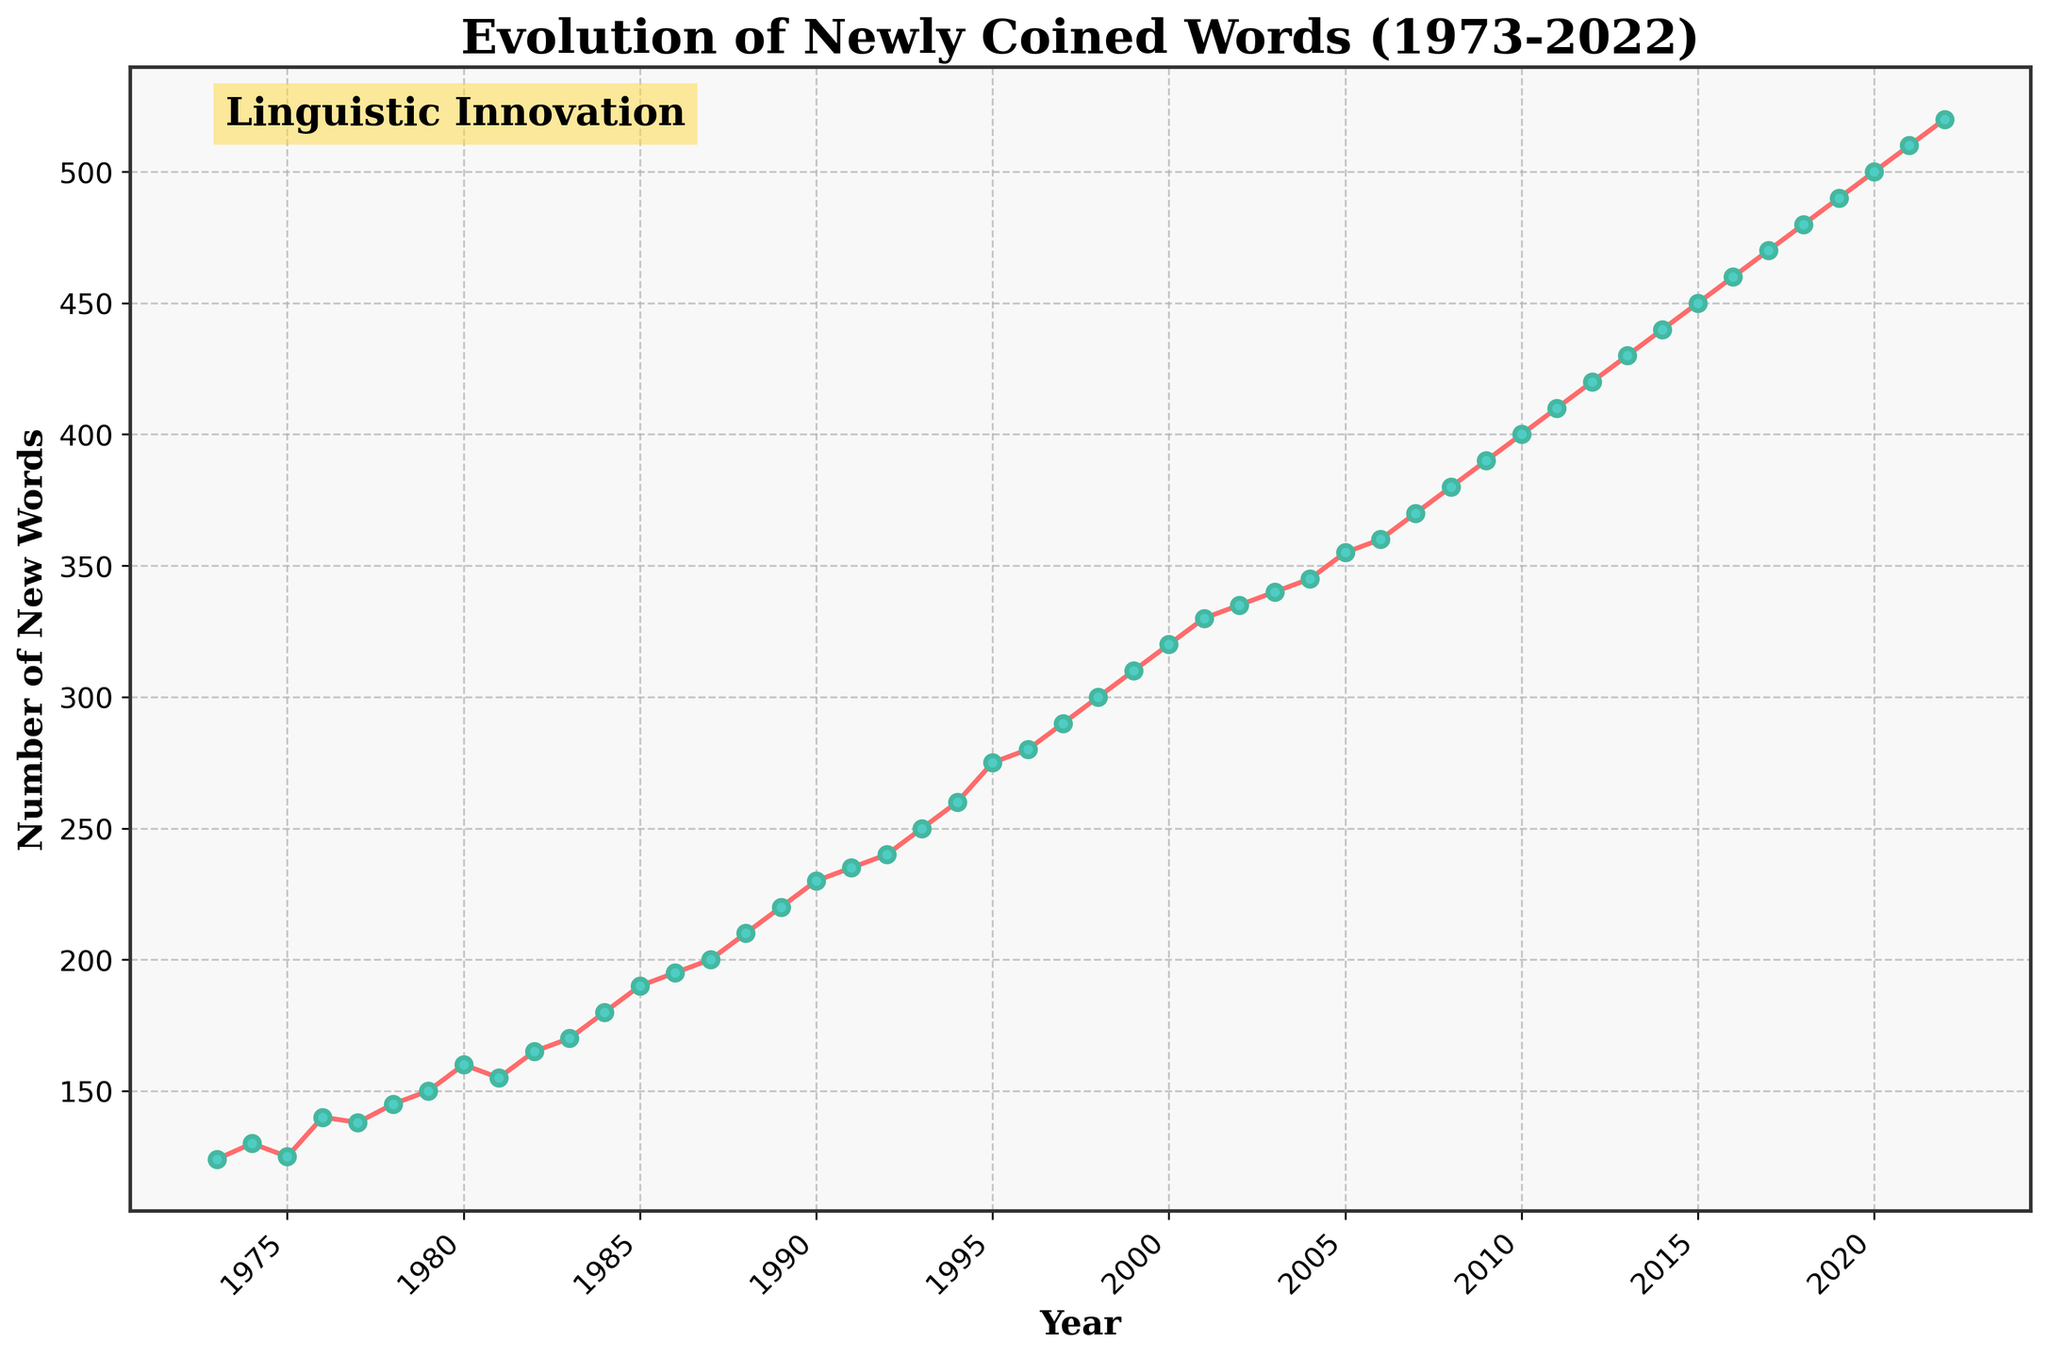What is the title of the plot? The title is located at the top center of the plot. By examining the figure, the title reads "Evolution of Newly Coined Words (1973-2022)."
Answer: Evolution of Newly Coined Words (1973-2022) What does the y-axis represent? The y-axis typically represents the variable of interest in a time series plot. Here, it is labeled "Number of New Words," denoting the count of newly coined words.
Answer: Number of New Words How many years does the data span? By looking at the x-axis, we can see the range of years from the start to the end. It begins at 1973 and ends at 2022. The timespan is 2022 - 1973 + 1 (inclusive).
Answer: 50 years In which year did the count of newly coined words reach 500? Reviewing the plot and y-axis, we find the point where the count is closest to 500, which falls on the year 2020.
Answer: 2020 What was the number of new words in 1985? By locating the year 1985 on the x-axis and tracing upward to intersect the line, the y-axis indicates the count, which is 190.
Answer: 190 What is the average number of newly coined words from 1973 to 1983? To find the average, sum the counts from 1973 to 1983 and divide by the number of years (11). This is (124 + 130 + 125 + 140 + 138 + 145 + 150 + 160 + 155 + 165 + 170) / 11.
Answer: 149 Compare the number of new words in 1990 and 2000. Which year had more newly coined words? By examining the y-axis values for the years 1990 and 2000, we see that 1990 had 230 and 2000 had 320. Thus, the year 2000 had more newly coined words.
Answer: 2000 From 1980 to 1990, which year had the steepest increase in newly coined words? By evaluating the slope of the line between successive years from 1980 to 1990, the year-to-year differences can be compared. The steepest increase occurs between 1984 (180) and 1985 (190), a change of +10.
Answer: 1985 What was the rate of increase in newly coined words per year from 2010 to 2020? Calculate the difference in counts between 2020 and 2010, then divide by the number of years. (500 - 400) / (2020 - 2010) = 10 words per year.
Answer: 10 words per year Identify the decade with the highest overall increase in newly coined words. Compare the increases in counts across each decade: 1973-1983, 1983-1993, etc. The steepest rise appears between 2010 and 2020, with an increase from 400 to 500.
Answer: 2010-2020 